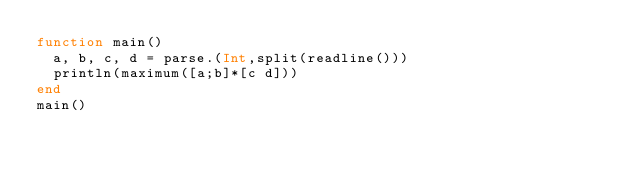<code> <loc_0><loc_0><loc_500><loc_500><_Julia_>function main()
  a, b, c, d = parse.(Int,split(readline()))
  println(maximum([a;b]*[c d]))
end
main()
</code> 